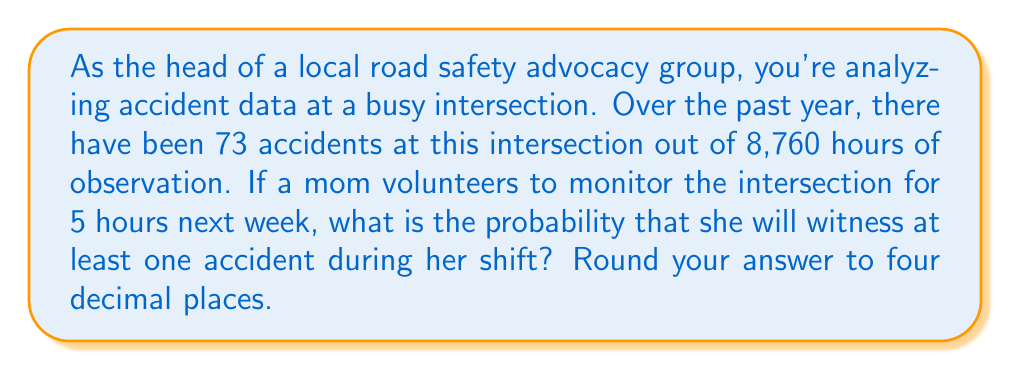What is the answer to this math problem? To solve this problem, we'll use the concept of probability and the complement rule.

1) First, let's calculate the probability of an accident occurring in any given hour:
   $P(\text{accident in 1 hour}) = \frac{73 \text{ accidents}}{8760 \text{ hours}} = \frac{73}{8760} \approx 0.00833$

2) Now, we need to find the probability of at least one accident in 5 hours. It's easier to calculate the probability of no accidents in 5 hours and then subtract from 1.

3) The probability of no accident in one hour is:
   $P(\text{no accident in 1 hour}) = 1 - P(\text{accident in 1 hour}) = 1 - \frac{73}{8760} = \frac{8687}{8760}$

4) For no accidents in 5 hours, this needs to happen 5 times in a row. Assuming independence:
   $P(\text{no accident in 5 hours}) = (\frac{8687}{8760})^5$

5) Therefore, the probability of at least one accident in 5 hours is:
   $$P(\text{at least one accident in 5 hours}) = 1 - P(\text{no accident in 5 hours})$$
   $$= 1 - (\frac{8687}{8760})^5$$
   $$= 1 - 0.9586$$
   $$= 0.0414$$

6) Rounding to four decimal places: 0.0414
Answer: 0.0414 